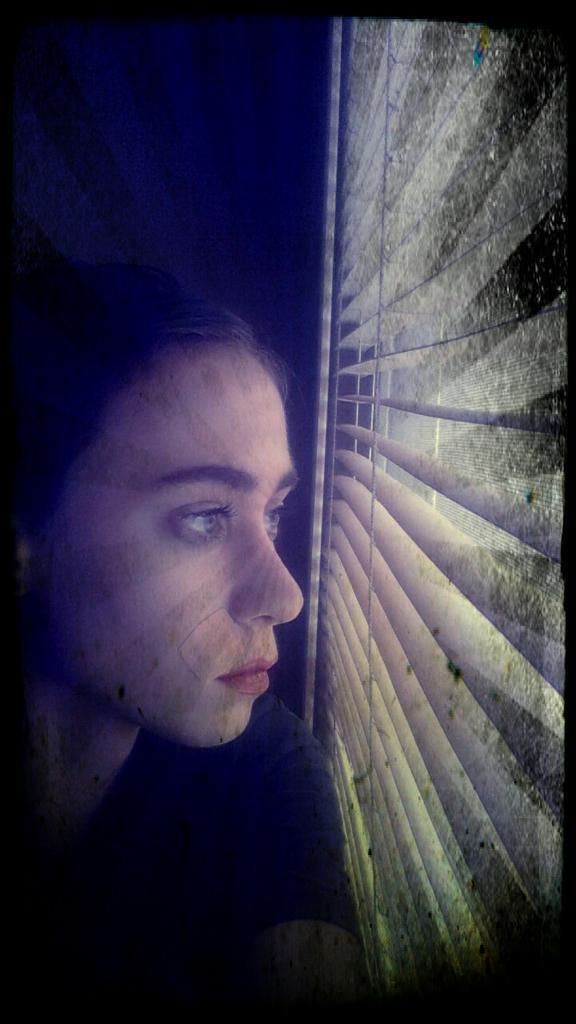What is the main subject of the image? There is a person in the image. Where is the person located in relation to other objects in the image? The person is near the window shutter. What type of milk is the person drinking in the image? There is no milk present in the image, and the person's actions are not described. What territory does the person own in the image? There is no mention of territory in the image, and the person's ownership is not described. 